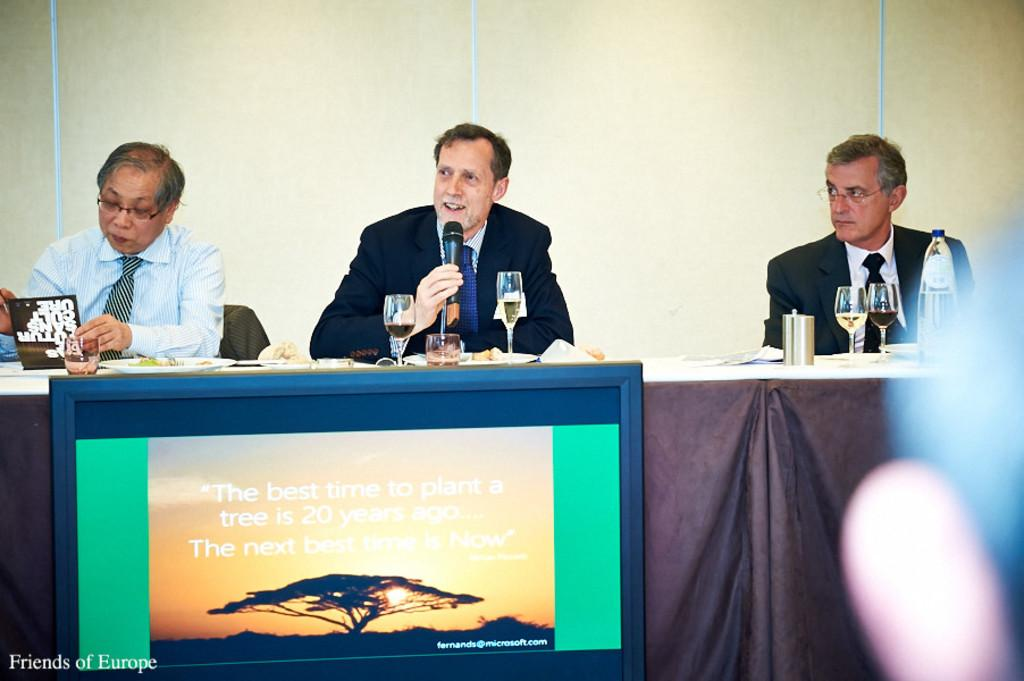Provide a one-sentence caption for the provided image. A sign telling people that the best time to plant a tree was 20 years ago. 